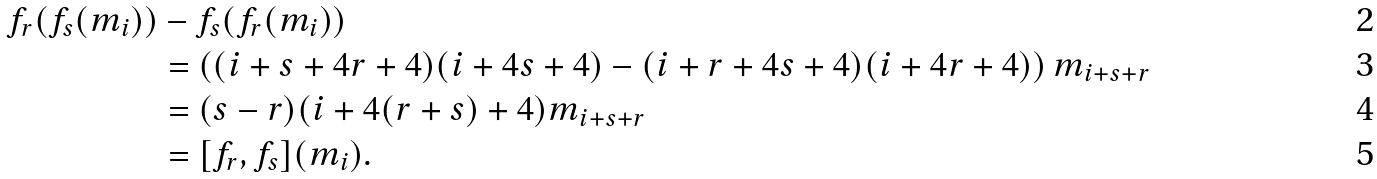Convert formula to latex. <formula><loc_0><loc_0><loc_500><loc_500>f _ { r } ( f _ { s } ( m _ { i } ) ) & - f _ { s } ( f _ { r } ( m _ { i } ) ) \\ & = \left ( ( i + s + 4 r + 4 ) ( i + 4 s + 4 ) - ( i + r + 4 s + 4 ) ( i + 4 r + 4 ) \right ) m _ { i + s + r } \\ & = ( s - r ) ( i + 4 ( r + s ) + 4 ) m _ { i + s + r } \\ & = [ f _ { r } , f _ { s } ] ( m _ { i } ) .</formula> 